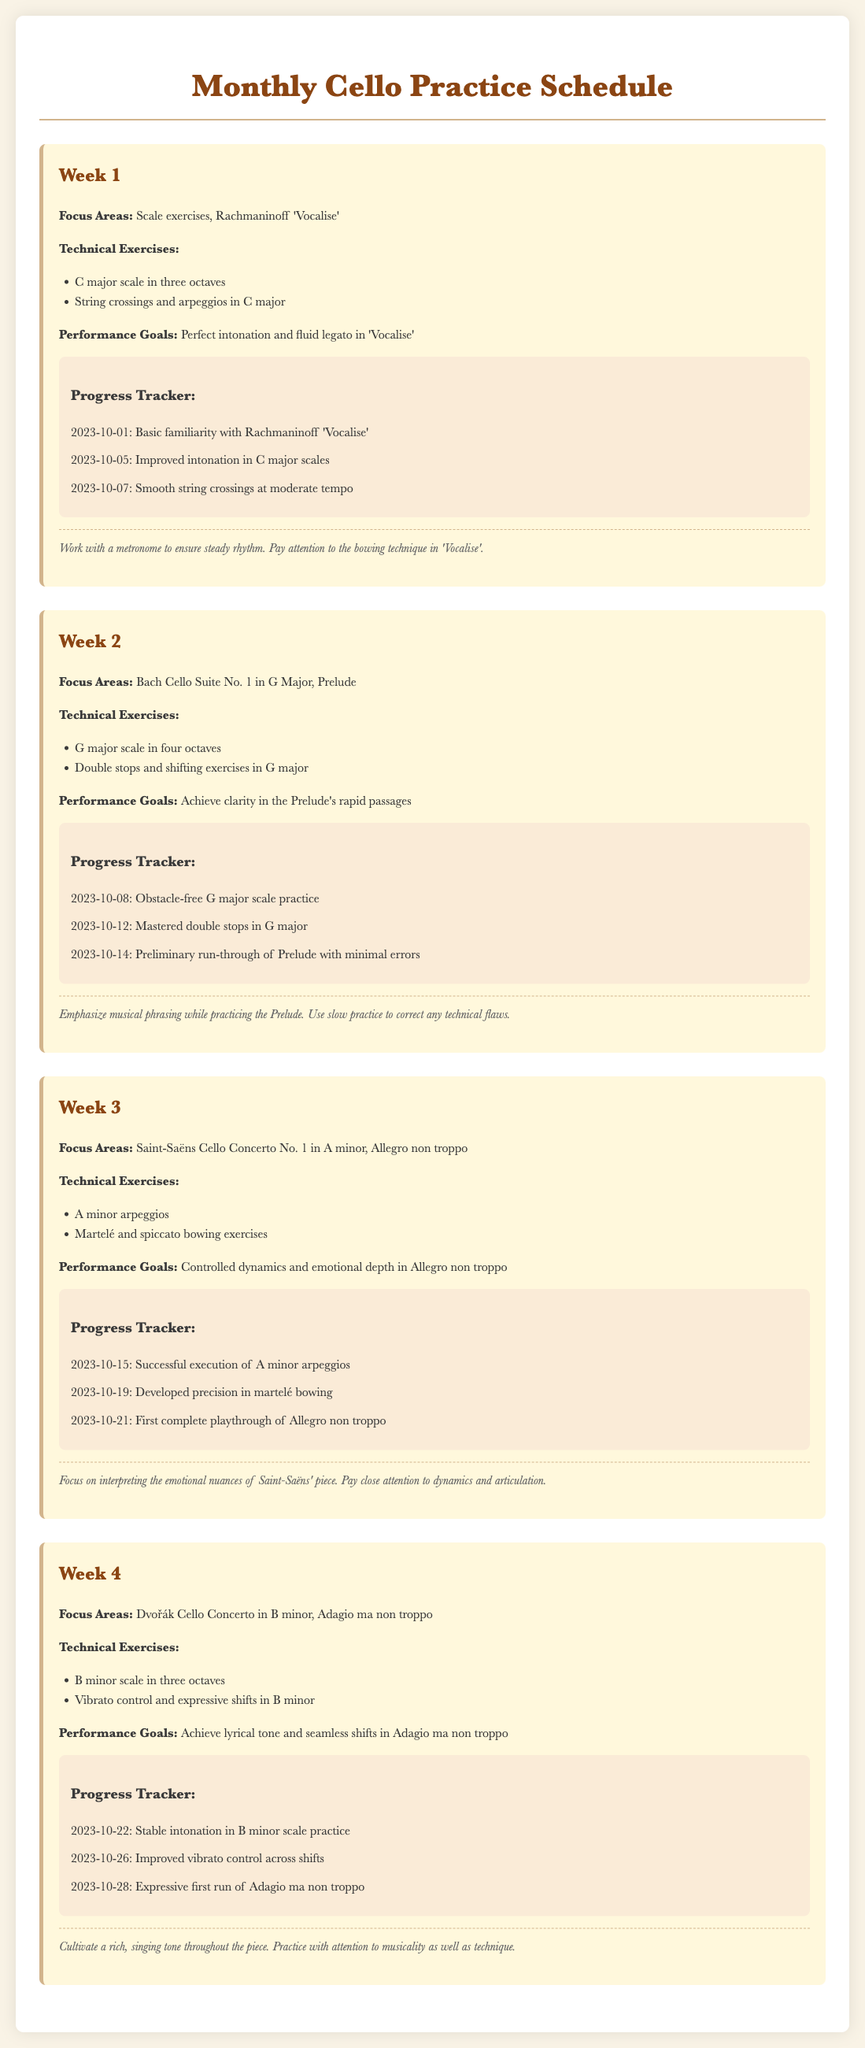What is the focus area for Week 1? The focus area for Week 1 is mentioned in the document, which is "Scale exercises, Rachmaninoff 'Vocalise'."
Answer: Scale exercises, Rachmaninoff 'Vocalise' How many octaves for the G major scale in Week 2? The document specifies that the G major scale is to be practiced in four octaves in Week 2.
Answer: four octaves What are the performance goals for Week 3? The performance goals for Week 3 are related to the piece being focused on, specifically "Controlled dynamics and emotional depth in Allegro non troppo."
Answer: Controlled dynamics and emotional depth in Allegro non troppo How many progress items are listed in Week 4? The document contains three progress items listed under Week 4, tracking achievements over time.
Answer: three What technical exercises are prescribed for Week 2? The document outlines specific technical exercises for Week 2, which are "G major scale in four octaves" and "Double stops and shifting exercises in G major."
Answer: G major scale in four octaves, Double stops and shifting exercises in G major What is the date of the first complete playthrough in Week 3? The document specifies the date for the first complete playthrough of Allegro non troppo, which is "2023-10-21."
Answer: 2023-10-21 What annotation advice is provided for Week 1? The document contains specific annotations for Week 1, including advice to "Work with a metronome to ensure steady rhythm."
Answer: Work with a metronome to ensure steady rhythm What is the focus area for Week 4? The focus area for Week 4 is detailed in the document as "Dvořák Cello Concerto in B minor, Adagio ma non troppo."
Answer: Dvořák Cello Concerto in B minor, Adagio ma non troppo 